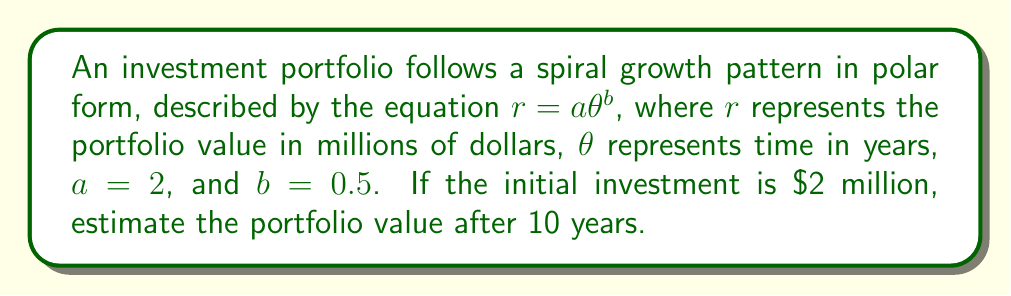What is the answer to this math problem? To solve this problem, we'll follow these steps:

1) The spiral growth pattern is given by the equation $r = a\theta^b$, where:
   $r$ = portfolio value in millions of dollars
   $\theta$ = time in years
   $a = 2$
   $b = 0.5$

2) We need to find $r$ when $\theta = 10$ years.

3) Substituting the values into the equation:

   $r = 2 * 10^{0.5}$

4) Calculate $10^{0.5}$:
   
   $10^{0.5} = \sqrt{10} \approx 3.16228$

5) Multiply by 2:

   $r = 2 * 3.16228 \approx 6.32456$

6) Therefore, after 10 years, the portfolio value will be approximately $6.32456 million.

[asy]
import graph;
size(200);
real f(real x) {return 2*sqrt(x);}
draw(polargraph(f,0,10),blue);
dot((2,0),red);
dot((f(10)*cos(10),f(10)*sin(10)),red);
label("Start",(2,0),SE);
label("10 years",(f(10)*cos(10),f(10)*sin(10)),NE);
xaxis("",arrow=Arrow);
yaxis("",arrow=Arrow);
[/asy]

The graph shows the spiral growth of the investment over time, with the starting point and the 10-year mark highlighted.
Answer: $6.32 million 